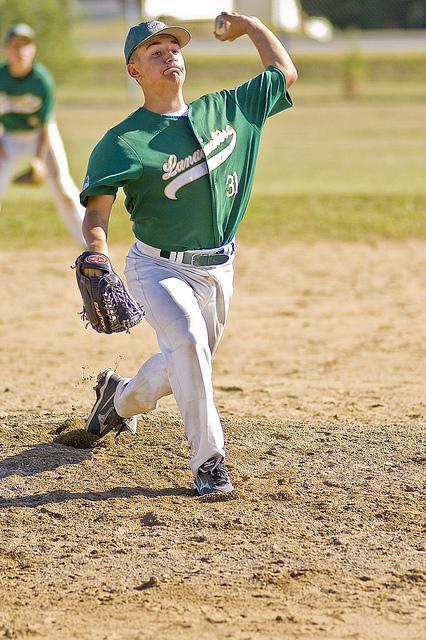How many people are there?
Give a very brief answer. 2. 